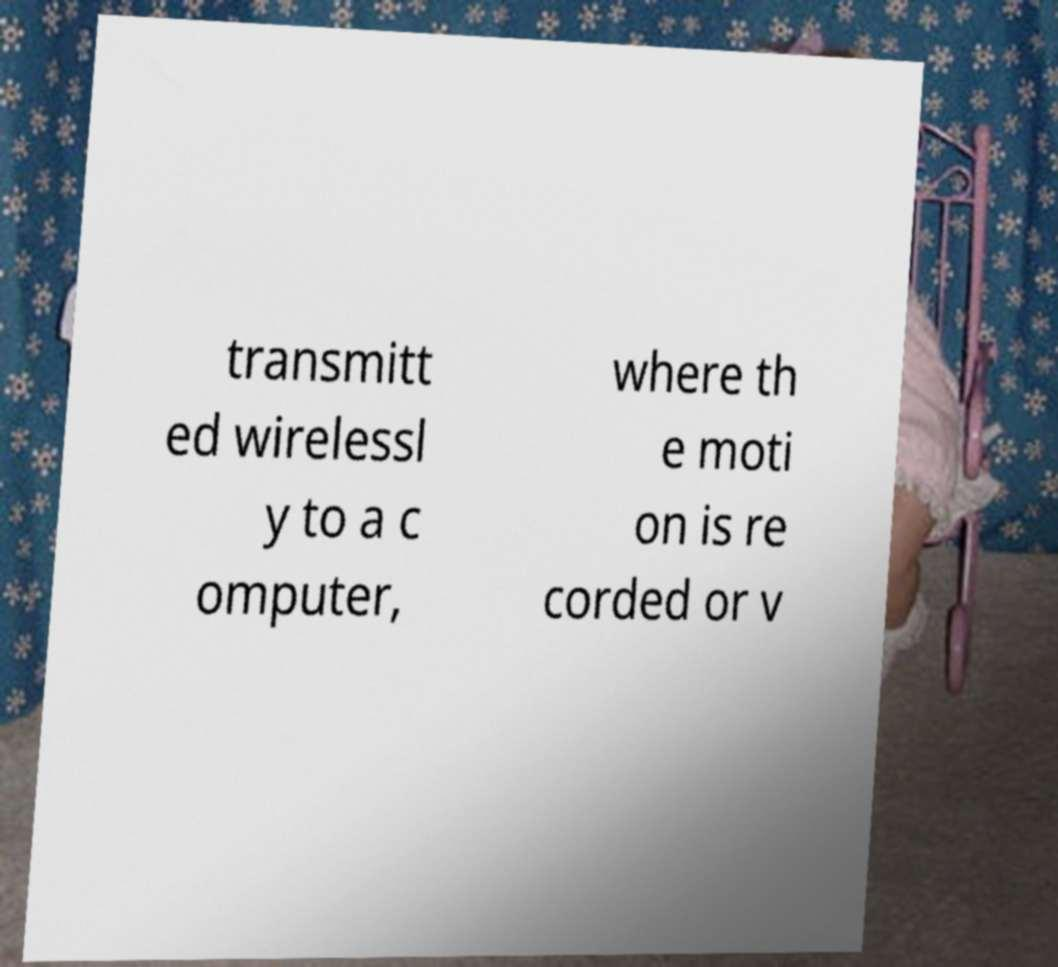Please identify and transcribe the text found in this image. transmitt ed wirelessl y to a c omputer, where th e moti on is re corded or v 